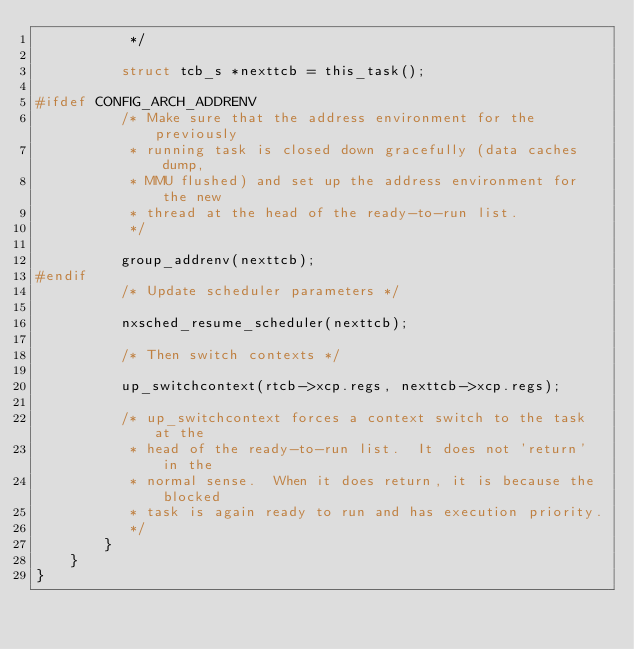Convert code to text. <code><loc_0><loc_0><loc_500><loc_500><_C_>           */

          struct tcb_s *nexttcb = this_task();

#ifdef CONFIG_ARCH_ADDRENV
          /* Make sure that the address environment for the previously
           * running task is closed down gracefully (data caches dump,
           * MMU flushed) and set up the address environment for the new
           * thread at the head of the ready-to-run list.
           */

          group_addrenv(nexttcb);
#endif
          /* Update scheduler parameters */

          nxsched_resume_scheduler(nexttcb);

          /* Then switch contexts */

          up_switchcontext(rtcb->xcp.regs, nexttcb->xcp.regs);

          /* up_switchcontext forces a context switch to the task at the
           * head of the ready-to-run list.  It does not 'return' in the
           * normal sense.  When it does return, it is because the blocked
           * task is again ready to run and has execution priority.
           */
        }
    }
}
</code> 